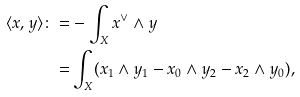Convert formula to latex. <formula><loc_0><loc_0><loc_500><loc_500>\langle x , y \rangle \colon = & - \int _ { X } x ^ { \vee } \wedge y \\ = & \int _ { X } ( x _ { 1 } \wedge y _ { 1 } - x _ { 0 } \wedge y _ { 2 } - x _ { 2 } \wedge y _ { 0 } ) ,</formula> 